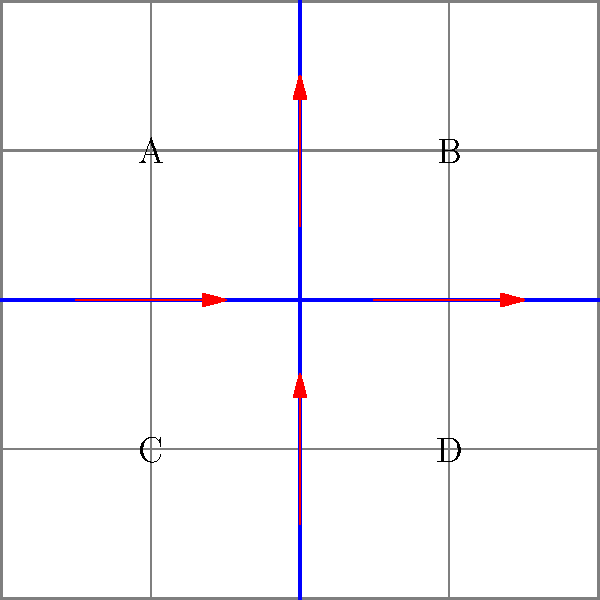As a journalist investigating historical inaccuracies in textbooks, you've come across a controversial claim about urban planning. The diagram shows a simplified city street layout with four quadrants (A, B, C, D) and bidirectional traffic flow on two main streets. If the city decides to implement a one-way system on both streets to improve traffic flow, which quadrant is likely to experience the most significant change in accessibility, and why? Consider how this change might affect the narrative of urban development in historical texts. To answer this question, we need to analyze the impact of changing from a bidirectional to a one-way traffic system on each quadrant:

1. Current situation:
   - All quadrants have equal access with two entry and two exit points.

2. One-way system implementation:
   - Assume the horizontal street flows from left to right, and the vertical street flows from bottom to top.

3. Impact on each quadrant:
   A. Quadrant A: Loses direct access from the right and from below.
   B. Quadrant B: Loses direct access from the left and from below.
   C. Quadrant C: Loses direct access from the right and from above.
   D. Quadrant D: Loses direct access from the left and from above.

4. Accessibility changes:
   - Quadrants A and D lose inbound access but retain outbound access.
   - Quadrants B and C lose outbound access but retain inbound access.

5. Most significant change:
   - Quadrant C experiences the most significant change because it loses all direct outbound access.
   - Vehicles in Quadrant C must first travel through other quadrants to exit the area.

6. Historical narrative impact:
   - This change could affect how historians interpret the development of the area.
   - It might lead to a reassessment of economic growth patterns, population distribution, and social dynamics in the quadrants over time.

The one-way system would likely cause a shift in traffic patterns, potentially leading to increased congestion in some areas and reduced accessibility in others. This could challenge existing historical accounts of urban development and necessitate a reevaluation of how transportation infrastructure has shaped the city's growth and social fabric.
Answer: Quadrant C, due to loss of all direct outbound access. 